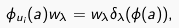<formula> <loc_0><loc_0><loc_500><loc_500>\phi _ { u _ { i } } ( a ) w _ { \lambda } = w _ { \lambda } \delta _ { \lambda } ( \phi ( a ) ) ,</formula> 